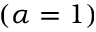Convert formula to latex. <formula><loc_0><loc_0><loc_500><loc_500>( \alpha = 1 )</formula> 